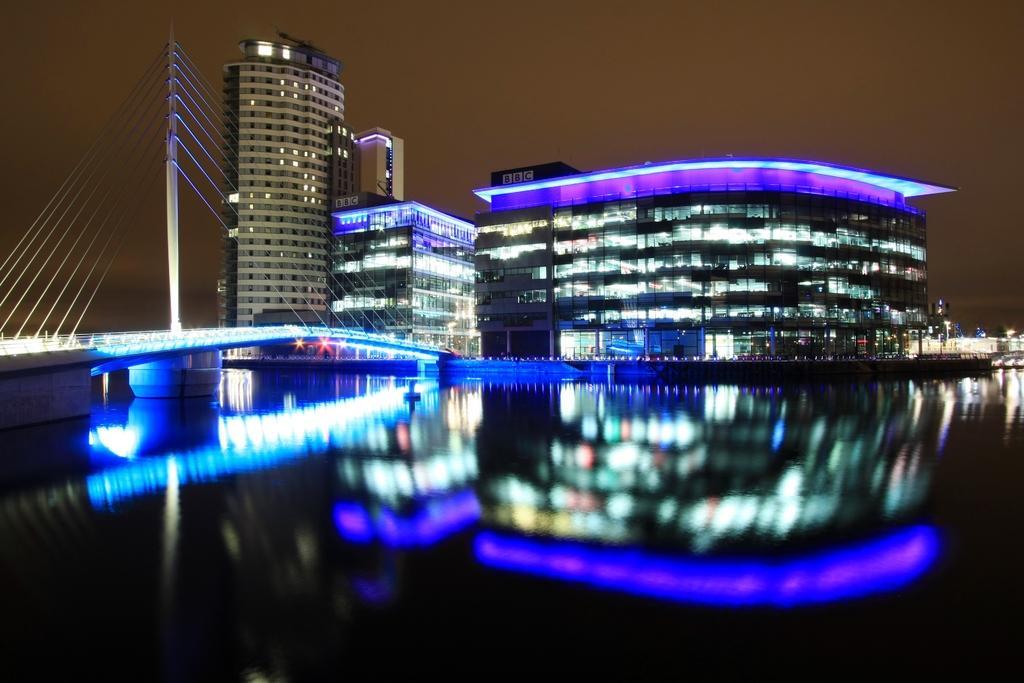Please provide a concise description of this image. In this picture, there are buildings with purple lights at the top. At the bottom there is water and reflection of buildings can be seen. Towards the left, there is a bridge with ropes and a pole. 